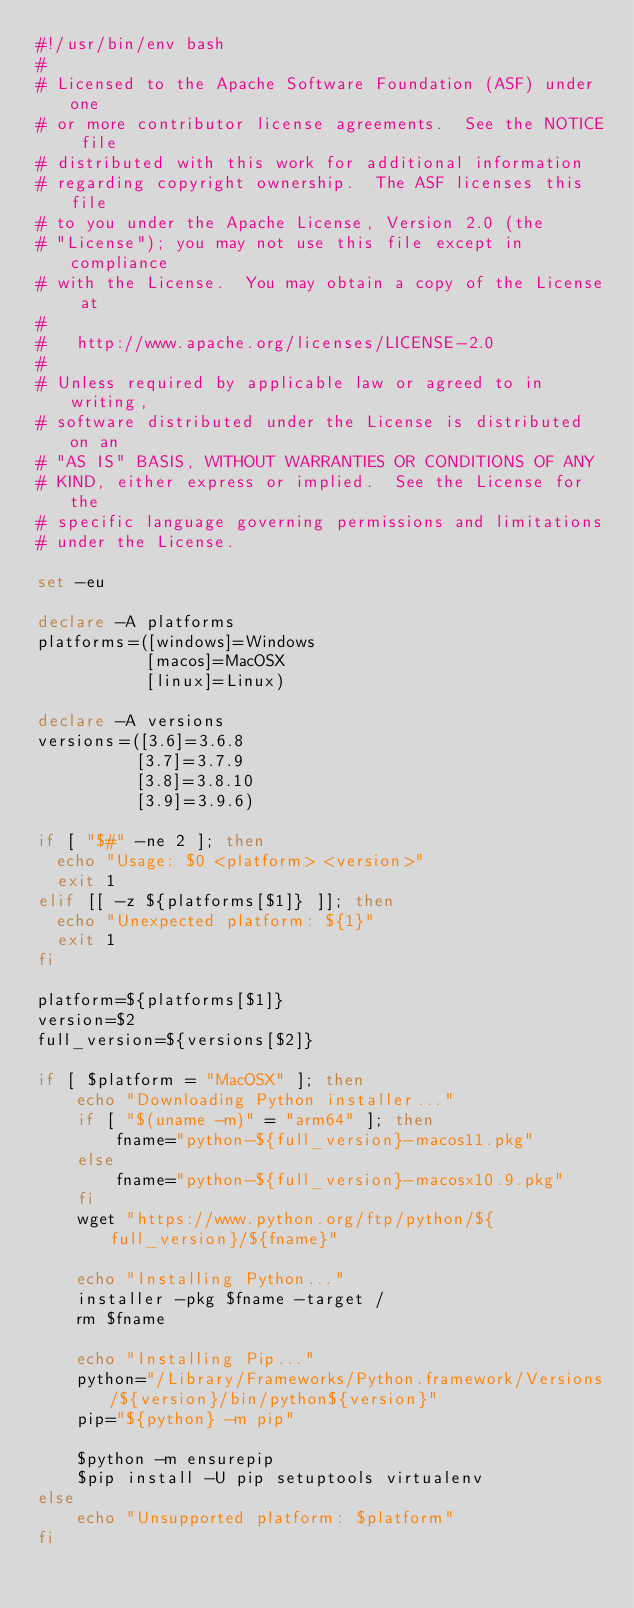<code> <loc_0><loc_0><loc_500><loc_500><_Bash_>#!/usr/bin/env bash
#
# Licensed to the Apache Software Foundation (ASF) under one
# or more contributor license agreements.  See the NOTICE file
# distributed with this work for additional information
# regarding copyright ownership.  The ASF licenses this file
# to you under the Apache License, Version 2.0 (the
# "License"); you may not use this file except in compliance
# with the License.  You may obtain a copy of the License at
#
#   http://www.apache.org/licenses/LICENSE-2.0
#
# Unless required by applicable law or agreed to in writing,
# software distributed under the License is distributed on an
# "AS IS" BASIS, WITHOUT WARRANTIES OR CONDITIONS OF ANY
# KIND, either express or implied.  See the License for the
# specific language governing permissions and limitations
# under the License.

set -eu

declare -A platforms
platforms=([windows]=Windows
           [macos]=MacOSX
           [linux]=Linux)

declare -A versions
versions=([3.6]=3.6.8
          [3.7]=3.7.9
          [3.8]=3.8.10
          [3.9]=3.9.6)

if [ "$#" -ne 2 ]; then
  echo "Usage: $0 <platform> <version>"
  exit 1
elif [[ -z ${platforms[$1]} ]]; then
  echo "Unexpected platform: ${1}"
  exit 1
fi

platform=${platforms[$1]}
version=$2
full_version=${versions[$2]}

if [ $platform = "MacOSX" ]; then
    echo "Downloading Python installer..."
    if [ "$(uname -m)" = "arm64" ]; then
        fname="python-${full_version}-macos11.pkg"
    else
        fname="python-${full_version}-macosx10.9.pkg"
    fi
    wget "https://www.python.org/ftp/python/${full_version}/${fname}"

    echo "Installing Python..."
    installer -pkg $fname -target /
    rm $fname

    echo "Installing Pip..."
    python="/Library/Frameworks/Python.framework/Versions/${version}/bin/python${version}"
    pip="${python} -m pip"

    $python -m ensurepip
    $pip install -U pip setuptools virtualenv
else
    echo "Unsupported platform: $platform"
fi
</code> 